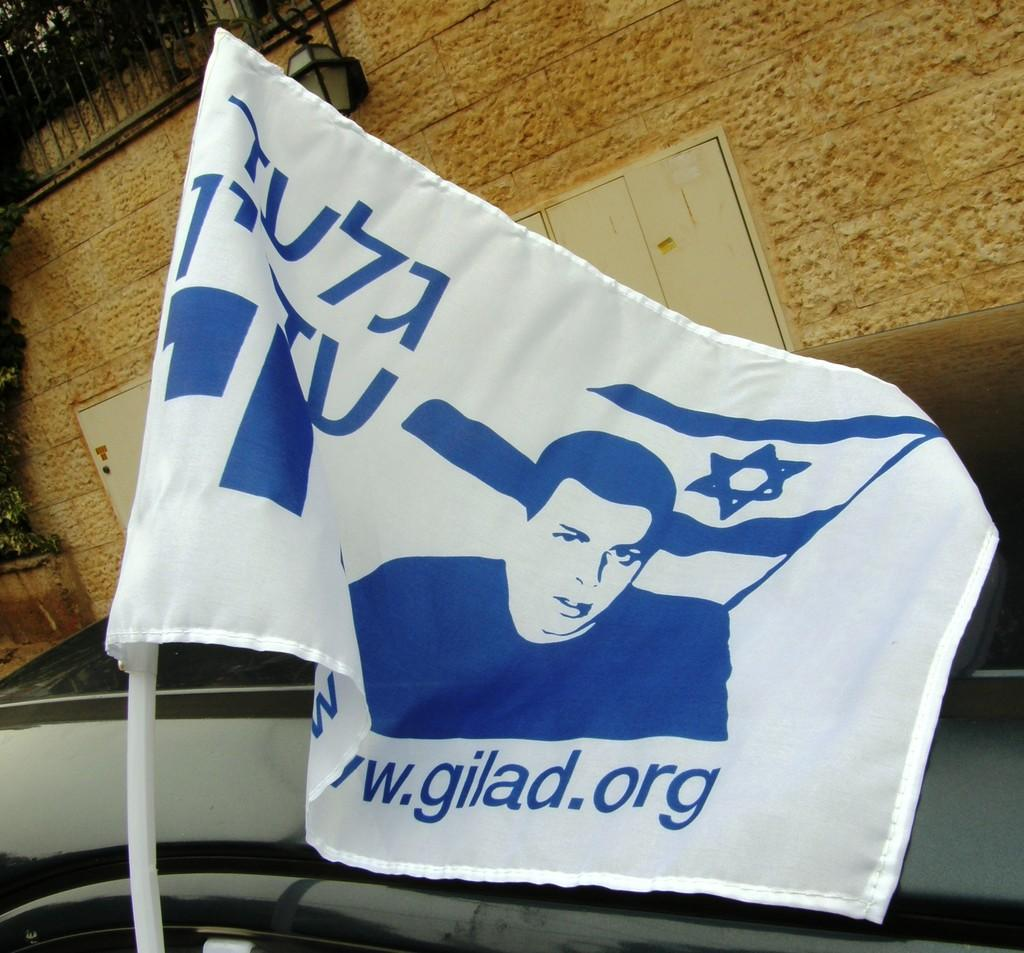What type of object is the main subject in the image? There is a vehicle in the image. What additional object can be seen in the image? There is a flag in the image. What type of structure is visible in the image? There is a building in the image. What type of barrier is present in the image? There is a fence in the image. What type of lighting fixture is visible in the image? There is a street lamp in the image. What type of celery is being used to decorate the vehicle in the image? There is no celery present in the image; it is a vehicle with a flag, building, fence, and street lamp. How many boys are visible in the image? There are no boys visible in the image. 